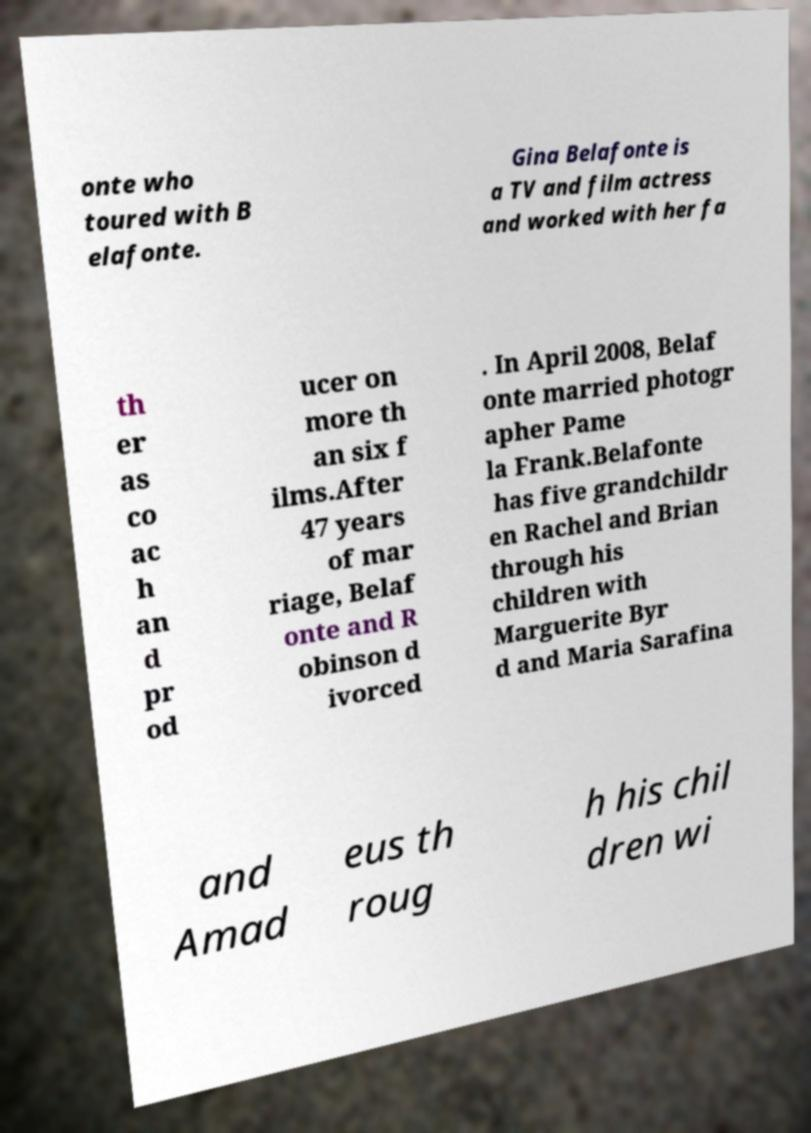I need the written content from this picture converted into text. Can you do that? onte who toured with B elafonte. Gina Belafonte is a TV and film actress and worked with her fa th er as co ac h an d pr od ucer on more th an six f ilms.After 47 years of mar riage, Belaf onte and R obinson d ivorced . In April 2008, Belaf onte married photogr apher Pame la Frank.Belafonte has five grandchildr en Rachel and Brian through his children with Marguerite Byr d and Maria Sarafina and Amad eus th roug h his chil dren wi 